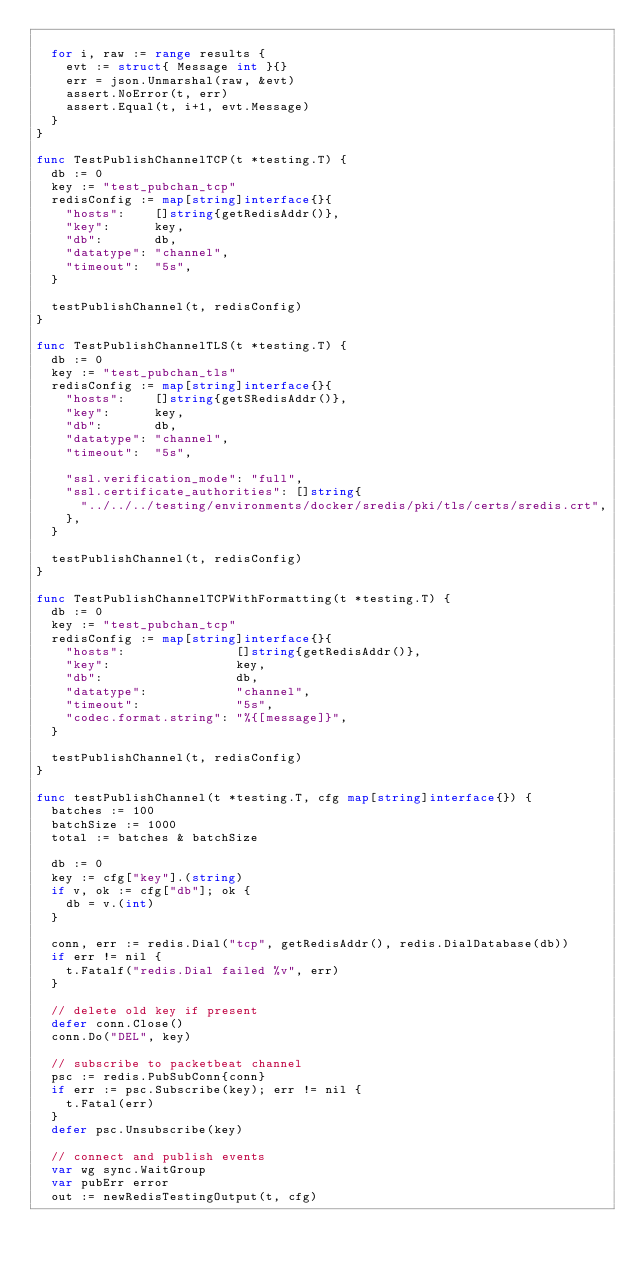<code> <loc_0><loc_0><loc_500><loc_500><_Go_>
	for i, raw := range results {
		evt := struct{ Message int }{}
		err = json.Unmarshal(raw, &evt)
		assert.NoError(t, err)
		assert.Equal(t, i+1, evt.Message)
	}
}

func TestPublishChannelTCP(t *testing.T) {
	db := 0
	key := "test_pubchan_tcp"
	redisConfig := map[string]interface{}{
		"hosts":    []string{getRedisAddr()},
		"key":      key,
		"db":       db,
		"datatype": "channel",
		"timeout":  "5s",
	}

	testPublishChannel(t, redisConfig)
}

func TestPublishChannelTLS(t *testing.T) {
	db := 0
	key := "test_pubchan_tls"
	redisConfig := map[string]interface{}{
		"hosts":    []string{getSRedisAddr()},
		"key":      key,
		"db":       db,
		"datatype": "channel",
		"timeout":  "5s",

		"ssl.verification_mode": "full",
		"ssl.certificate_authorities": []string{
			"../../../testing/environments/docker/sredis/pki/tls/certs/sredis.crt",
		},
	}

	testPublishChannel(t, redisConfig)
}

func TestPublishChannelTCPWithFormatting(t *testing.T) {
	db := 0
	key := "test_pubchan_tcp"
	redisConfig := map[string]interface{}{
		"hosts":               []string{getRedisAddr()},
		"key":                 key,
		"db":                  db,
		"datatype":            "channel",
		"timeout":             "5s",
		"codec.format.string": "%{[message]}",
	}

	testPublishChannel(t, redisConfig)
}

func testPublishChannel(t *testing.T, cfg map[string]interface{}) {
	batches := 100
	batchSize := 1000
	total := batches & batchSize

	db := 0
	key := cfg["key"].(string)
	if v, ok := cfg["db"]; ok {
		db = v.(int)
	}

	conn, err := redis.Dial("tcp", getRedisAddr(), redis.DialDatabase(db))
	if err != nil {
		t.Fatalf("redis.Dial failed %v", err)
	}

	// delete old key if present
	defer conn.Close()
	conn.Do("DEL", key)

	// subscribe to packetbeat channel
	psc := redis.PubSubConn{conn}
	if err := psc.Subscribe(key); err != nil {
		t.Fatal(err)
	}
	defer psc.Unsubscribe(key)

	// connect and publish events
	var wg sync.WaitGroup
	var pubErr error
	out := newRedisTestingOutput(t, cfg)</code> 